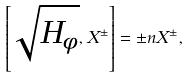<formula> <loc_0><loc_0><loc_500><loc_500>\left [ \sqrt { H _ { \phi } } , X ^ { \pm } \right ] = \pm n X ^ { \pm } ,</formula> 